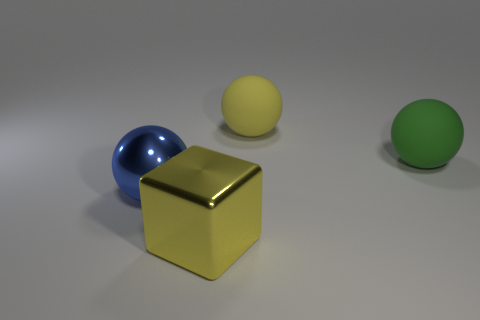Subtract all green spheres. How many spheres are left? 2 Subtract all blue cubes. How many blue balls are left? 1 Subtract all blue balls. How many balls are left? 2 Subtract all spheres. How many objects are left? 1 Subtract all cyan balls. Subtract all red blocks. How many balls are left? 3 Subtract all large yellow things. Subtract all yellow rubber objects. How many objects are left? 1 Add 3 spheres. How many spheres are left? 6 Add 1 large blue things. How many large blue things exist? 2 Add 4 red balls. How many objects exist? 8 Subtract 0 cyan blocks. How many objects are left? 4 